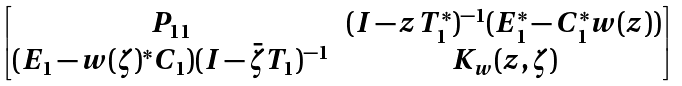<formula> <loc_0><loc_0><loc_500><loc_500>\begin{bmatrix} P _ { 1 1 } & ( I - z T _ { 1 } ^ { * } ) ^ { - 1 } ( E _ { 1 } ^ { * } - C _ { 1 } ^ { * } w ( z ) ) \\ ( E _ { 1 } - w ( \zeta ) ^ { * } C _ { 1 } ) ( I - \bar { \zeta } T _ { 1 } ) ^ { - 1 } & K _ { w } ( z , \zeta ) \end{bmatrix}</formula> 